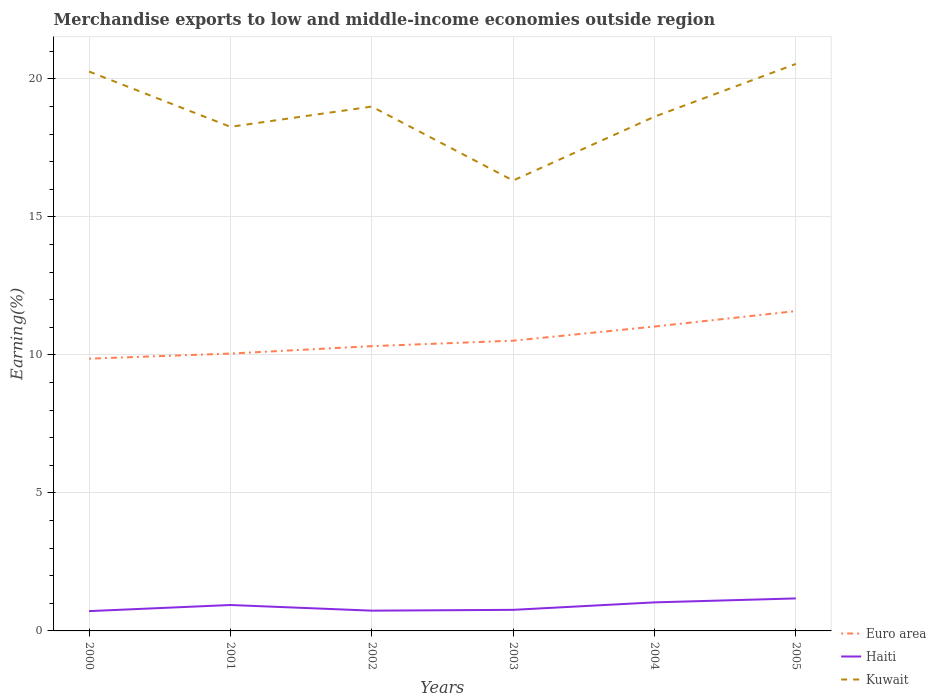How many different coloured lines are there?
Your response must be concise. 3. Across all years, what is the maximum percentage of amount earned from merchandise exports in Euro area?
Your response must be concise. 9.86. What is the total percentage of amount earned from merchandise exports in Haiti in the graph?
Give a very brief answer. -0.32. What is the difference between the highest and the second highest percentage of amount earned from merchandise exports in Kuwait?
Provide a short and direct response. 4.22. What is the difference between the highest and the lowest percentage of amount earned from merchandise exports in Kuwait?
Your answer should be compact. 3. Is the percentage of amount earned from merchandise exports in Haiti strictly greater than the percentage of amount earned from merchandise exports in Euro area over the years?
Ensure brevity in your answer.  Yes. How many years are there in the graph?
Give a very brief answer. 6. Does the graph contain any zero values?
Make the answer very short. No. Does the graph contain grids?
Your answer should be compact. Yes. How many legend labels are there?
Keep it short and to the point. 3. What is the title of the graph?
Give a very brief answer. Merchandise exports to low and middle-income economies outside region. Does "France" appear as one of the legend labels in the graph?
Provide a short and direct response. No. What is the label or title of the X-axis?
Provide a short and direct response. Years. What is the label or title of the Y-axis?
Offer a terse response. Earning(%). What is the Earning(%) of Euro area in 2000?
Your answer should be very brief. 9.86. What is the Earning(%) of Haiti in 2000?
Offer a very short reply. 0.72. What is the Earning(%) in Kuwait in 2000?
Ensure brevity in your answer.  20.26. What is the Earning(%) in Euro area in 2001?
Your response must be concise. 10.05. What is the Earning(%) of Haiti in 2001?
Your answer should be very brief. 0.94. What is the Earning(%) in Kuwait in 2001?
Offer a terse response. 18.26. What is the Earning(%) of Euro area in 2002?
Provide a succinct answer. 10.32. What is the Earning(%) in Haiti in 2002?
Your answer should be compact. 0.73. What is the Earning(%) of Kuwait in 2002?
Your answer should be compact. 18.99. What is the Earning(%) of Euro area in 2003?
Ensure brevity in your answer.  10.51. What is the Earning(%) in Haiti in 2003?
Make the answer very short. 0.76. What is the Earning(%) in Kuwait in 2003?
Your answer should be compact. 16.31. What is the Earning(%) of Euro area in 2004?
Provide a short and direct response. 11.03. What is the Earning(%) in Haiti in 2004?
Make the answer very short. 1.03. What is the Earning(%) of Kuwait in 2004?
Your answer should be very brief. 18.63. What is the Earning(%) of Euro area in 2005?
Your answer should be very brief. 11.59. What is the Earning(%) in Haiti in 2005?
Provide a succinct answer. 1.18. What is the Earning(%) of Kuwait in 2005?
Your response must be concise. 20.54. Across all years, what is the maximum Earning(%) in Euro area?
Offer a terse response. 11.59. Across all years, what is the maximum Earning(%) of Haiti?
Keep it short and to the point. 1.18. Across all years, what is the maximum Earning(%) in Kuwait?
Give a very brief answer. 20.54. Across all years, what is the minimum Earning(%) of Euro area?
Make the answer very short. 9.86. Across all years, what is the minimum Earning(%) of Haiti?
Keep it short and to the point. 0.72. Across all years, what is the minimum Earning(%) of Kuwait?
Give a very brief answer. 16.31. What is the total Earning(%) of Euro area in the graph?
Provide a short and direct response. 63.35. What is the total Earning(%) of Haiti in the graph?
Offer a very short reply. 5.37. What is the total Earning(%) of Kuwait in the graph?
Your response must be concise. 113. What is the difference between the Earning(%) in Euro area in 2000 and that in 2001?
Provide a short and direct response. -0.19. What is the difference between the Earning(%) of Haiti in 2000 and that in 2001?
Offer a very short reply. -0.22. What is the difference between the Earning(%) of Kuwait in 2000 and that in 2001?
Provide a succinct answer. 2. What is the difference between the Earning(%) in Euro area in 2000 and that in 2002?
Your answer should be very brief. -0.45. What is the difference between the Earning(%) of Haiti in 2000 and that in 2002?
Your answer should be compact. -0.02. What is the difference between the Earning(%) of Kuwait in 2000 and that in 2002?
Your answer should be very brief. 1.27. What is the difference between the Earning(%) of Euro area in 2000 and that in 2003?
Provide a succinct answer. -0.65. What is the difference between the Earning(%) in Haiti in 2000 and that in 2003?
Your response must be concise. -0.05. What is the difference between the Earning(%) in Kuwait in 2000 and that in 2003?
Give a very brief answer. 3.95. What is the difference between the Earning(%) of Euro area in 2000 and that in 2004?
Your answer should be compact. -1.16. What is the difference between the Earning(%) in Haiti in 2000 and that in 2004?
Provide a short and direct response. -0.32. What is the difference between the Earning(%) of Kuwait in 2000 and that in 2004?
Your answer should be very brief. 1.63. What is the difference between the Earning(%) in Euro area in 2000 and that in 2005?
Your response must be concise. -1.72. What is the difference between the Earning(%) of Haiti in 2000 and that in 2005?
Offer a terse response. -0.46. What is the difference between the Earning(%) in Kuwait in 2000 and that in 2005?
Your answer should be compact. -0.28. What is the difference between the Earning(%) of Euro area in 2001 and that in 2002?
Provide a short and direct response. -0.27. What is the difference between the Earning(%) in Haiti in 2001 and that in 2002?
Offer a terse response. 0.2. What is the difference between the Earning(%) in Kuwait in 2001 and that in 2002?
Your response must be concise. -0.73. What is the difference between the Earning(%) of Euro area in 2001 and that in 2003?
Your answer should be compact. -0.47. What is the difference between the Earning(%) of Haiti in 2001 and that in 2003?
Give a very brief answer. 0.18. What is the difference between the Earning(%) of Kuwait in 2001 and that in 2003?
Provide a succinct answer. 1.95. What is the difference between the Earning(%) in Euro area in 2001 and that in 2004?
Ensure brevity in your answer.  -0.98. What is the difference between the Earning(%) in Haiti in 2001 and that in 2004?
Give a very brief answer. -0.1. What is the difference between the Earning(%) of Kuwait in 2001 and that in 2004?
Offer a terse response. -0.37. What is the difference between the Earning(%) of Euro area in 2001 and that in 2005?
Provide a short and direct response. -1.54. What is the difference between the Earning(%) in Haiti in 2001 and that in 2005?
Ensure brevity in your answer.  -0.24. What is the difference between the Earning(%) in Kuwait in 2001 and that in 2005?
Provide a short and direct response. -2.28. What is the difference between the Earning(%) in Euro area in 2002 and that in 2003?
Offer a very short reply. -0.2. What is the difference between the Earning(%) of Haiti in 2002 and that in 2003?
Give a very brief answer. -0.03. What is the difference between the Earning(%) of Kuwait in 2002 and that in 2003?
Make the answer very short. 2.68. What is the difference between the Earning(%) in Euro area in 2002 and that in 2004?
Your answer should be compact. -0.71. What is the difference between the Earning(%) in Haiti in 2002 and that in 2004?
Ensure brevity in your answer.  -0.3. What is the difference between the Earning(%) in Kuwait in 2002 and that in 2004?
Your answer should be very brief. 0.37. What is the difference between the Earning(%) in Euro area in 2002 and that in 2005?
Provide a short and direct response. -1.27. What is the difference between the Earning(%) of Haiti in 2002 and that in 2005?
Provide a succinct answer. -0.44. What is the difference between the Earning(%) of Kuwait in 2002 and that in 2005?
Keep it short and to the point. -1.55. What is the difference between the Earning(%) of Euro area in 2003 and that in 2004?
Give a very brief answer. -0.51. What is the difference between the Earning(%) of Haiti in 2003 and that in 2004?
Your response must be concise. -0.27. What is the difference between the Earning(%) of Kuwait in 2003 and that in 2004?
Provide a short and direct response. -2.31. What is the difference between the Earning(%) in Euro area in 2003 and that in 2005?
Offer a terse response. -1.07. What is the difference between the Earning(%) of Haiti in 2003 and that in 2005?
Your answer should be very brief. -0.41. What is the difference between the Earning(%) of Kuwait in 2003 and that in 2005?
Keep it short and to the point. -4.22. What is the difference between the Earning(%) of Euro area in 2004 and that in 2005?
Offer a terse response. -0.56. What is the difference between the Earning(%) of Haiti in 2004 and that in 2005?
Offer a terse response. -0.14. What is the difference between the Earning(%) of Kuwait in 2004 and that in 2005?
Your answer should be compact. -1.91. What is the difference between the Earning(%) of Euro area in 2000 and the Earning(%) of Haiti in 2001?
Your response must be concise. 8.92. What is the difference between the Earning(%) of Euro area in 2000 and the Earning(%) of Kuwait in 2001?
Your answer should be compact. -8.4. What is the difference between the Earning(%) in Haiti in 2000 and the Earning(%) in Kuwait in 2001?
Offer a very short reply. -17.54. What is the difference between the Earning(%) of Euro area in 2000 and the Earning(%) of Haiti in 2002?
Keep it short and to the point. 9.13. What is the difference between the Earning(%) of Euro area in 2000 and the Earning(%) of Kuwait in 2002?
Keep it short and to the point. -9.13. What is the difference between the Earning(%) in Haiti in 2000 and the Earning(%) in Kuwait in 2002?
Provide a short and direct response. -18.28. What is the difference between the Earning(%) in Euro area in 2000 and the Earning(%) in Haiti in 2003?
Provide a short and direct response. 9.1. What is the difference between the Earning(%) in Euro area in 2000 and the Earning(%) in Kuwait in 2003?
Keep it short and to the point. -6.45. What is the difference between the Earning(%) of Haiti in 2000 and the Earning(%) of Kuwait in 2003?
Your answer should be compact. -15.6. What is the difference between the Earning(%) of Euro area in 2000 and the Earning(%) of Haiti in 2004?
Keep it short and to the point. 8.83. What is the difference between the Earning(%) in Euro area in 2000 and the Earning(%) in Kuwait in 2004?
Ensure brevity in your answer.  -8.77. What is the difference between the Earning(%) of Haiti in 2000 and the Earning(%) of Kuwait in 2004?
Offer a terse response. -17.91. What is the difference between the Earning(%) of Euro area in 2000 and the Earning(%) of Haiti in 2005?
Your answer should be very brief. 8.68. What is the difference between the Earning(%) of Euro area in 2000 and the Earning(%) of Kuwait in 2005?
Your answer should be compact. -10.68. What is the difference between the Earning(%) of Haiti in 2000 and the Earning(%) of Kuwait in 2005?
Offer a very short reply. -19.82. What is the difference between the Earning(%) in Euro area in 2001 and the Earning(%) in Haiti in 2002?
Make the answer very short. 9.31. What is the difference between the Earning(%) of Euro area in 2001 and the Earning(%) of Kuwait in 2002?
Your answer should be compact. -8.95. What is the difference between the Earning(%) of Haiti in 2001 and the Earning(%) of Kuwait in 2002?
Your answer should be very brief. -18.05. What is the difference between the Earning(%) in Euro area in 2001 and the Earning(%) in Haiti in 2003?
Your answer should be compact. 9.28. What is the difference between the Earning(%) of Euro area in 2001 and the Earning(%) of Kuwait in 2003?
Give a very brief answer. -6.27. What is the difference between the Earning(%) in Haiti in 2001 and the Earning(%) in Kuwait in 2003?
Give a very brief answer. -15.38. What is the difference between the Earning(%) in Euro area in 2001 and the Earning(%) in Haiti in 2004?
Offer a very short reply. 9.01. What is the difference between the Earning(%) of Euro area in 2001 and the Earning(%) of Kuwait in 2004?
Give a very brief answer. -8.58. What is the difference between the Earning(%) of Haiti in 2001 and the Earning(%) of Kuwait in 2004?
Ensure brevity in your answer.  -17.69. What is the difference between the Earning(%) of Euro area in 2001 and the Earning(%) of Haiti in 2005?
Provide a short and direct response. 8.87. What is the difference between the Earning(%) of Euro area in 2001 and the Earning(%) of Kuwait in 2005?
Your answer should be very brief. -10.49. What is the difference between the Earning(%) of Haiti in 2001 and the Earning(%) of Kuwait in 2005?
Provide a short and direct response. -19.6. What is the difference between the Earning(%) in Euro area in 2002 and the Earning(%) in Haiti in 2003?
Offer a terse response. 9.55. What is the difference between the Earning(%) of Euro area in 2002 and the Earning(%) of Kuwait in 2003?
Your answer should be compact. -6. What is the difference between the Earning(%) of Haiti in 2002 and the Earning(%) of Kuwait in 2003?
Provide a succinct answer. -15.58. What is the difference between the Earning(%) of Euro area in 2002 and the Earning(%) of Haiti in 2004?
Your response must be concise. 9.28. What is the difference between the Earning(%) in Euro area in 2002 and the Earning(%) in Kuwait in 2004?
Keep it short and to the point. -8.31. What is the difference between the Earning(%) of Haiti in 2002 and the Earning(%) of Kuwait in 2004?
Your response must be concise. -17.89. What is the difference between the Earning(%) of Euro area in 2002 and the Earning(%) of Haiti in 2005?
Your answer should be very brief. 9.14. What is the difference between the Earning(%) of Euro area in 2002 and the Earning(%) of Kuwait in 2005?
Your response must be concise. -10.22. What is the difference between the Earning(%) in Haiti in 2002 and the Earning(%) in Kuwait in 2005?
Give a very brief answer. -19.8. What is the difference between the Earning(%) in Euro area in 2003 and the Earning(%) in Haiti in 2004?
Offer a very short reply. 9.48. What is the difference between the Earning(%) of Euro area in 2003 and the Earning(%) of Kuwait in 2004?
Your answer should be compact. -8.11. What is the difference between the Earning(%) in Haiti in 2003 and the Earning(%) in Kuwait in 2004?
Give a very brief answer. -17.86. What is the difference between the Earning(%) of Euro area in 2003 and the Earning(%) of Haiti in 2005?
Your response must be concise. 9.34. What is the difference between the Earning(%) in Euro area in 2003 and the Earning(%) in Kuwait in 2005?
Your answer should be very brief. -10.03. What is the difference between the Earning(%) in Haiti in 2003 and the Earning(%) in Kuwait in 2005?
Your response must be concise. -19.77. What is the difference between the Earning(%) in Euro area in 2004 and the Earning(%) in Haiti in 2005?
Make the answer very short. 9.85. What is the difference between the Earning(%) of Euro area in 2004 and the Earning(%) of Kuwait in 2005?
Your answer should be compact. -9.51. What is the difference between the Earning(%) in Haiti in 2004 and the Earning(%) in Kuwait in 2005?
Give a very brief answer. -19.5. What is the average Earning(%) in Euro area per year?
Give a very brief answer. 10.56. What is the average Earning(%) of Haiti per year?
Keep it short and to the point. 0.89. What is the average Earning(%) of Kuwait per year?
Provide a short and direct response. 18.83. In the year 2000, what is the difference between the Earning(%) in Euro area and Earning(%) in Haiti?
Make the answer very short. 9.14. In the year 2000, what is the difference between the Earning(%) in Euro area and Earning(%) in Kuwait?
Offer a terse response. -10.4. In the year 2000, what is the difference between the Earning(%) of Haiti and Earning(%) of Kuwait?
Give a very brief answer. -19.54. In the year 2001, what is the difference between the Earning(%) of Euro area and Earning(%) of Haiti?
Offer a very short reply. 9.11. In the year 2001, what is the difference between the Earning(%) in Euro area and Earning(%) in Kuwait?
Keep it short and to the point. -8.21. In the year 2001, what is the difference between the Earning(%) of Haiti and Earning(%) of Kuwait?
Your response must be concise. -17.32. In the year 2002, what is the difference between the Earning(%) in Euro area and Earning(%) in Haiti?
Keep it short and to the point. 9.58. In the year 2002, what is the difference between the Earning(%) in Euro area and Earning(%) in Kuwait?
Ensure brevity in your answer.  -8.68. In the year 2002, what is the difference between the Earning(%) in Haiti and Earning(%) in Kuwait?
Offer a terse response. -18.26. In the year 2003, what is the difference between the Earning(%) in Euro area and Earning(%) in Haiti?
Provide a short and direct response. 9.75. In the year 2003, what is the difference between the Earning(%) in Euro area and Earning(%) in Kuwait?
Your response must be concise. -5.8. In the year 2003, what is the difference between the Earning(%) in Haiti and Earning(%) in Kuwait?
Offer a terse response. -15.55. In the year 2004, what is the difference between the Earning(%) in Euro area and Earning(%) in Haiti?
Ensure brevity in your answer.  9.99. In the year 2004, what is the difference between the Earning(%) in Euro area and Earning(%) in Kuwait?
Make the answer very short. -7.6. In the year 2004, what is the difference between the Earning(%) in Haiti and Earning(%) in Kuwait?
Offer a terse response. -17.59. In the year 2005, what is the difference between the Earning(%) in Euro area and Earning(%) in Haiti?
Offer a terse response. 10.41. In the year 2005, what is the difference between the Earning(%) in Euro area and Earning(%) in Kuwait?
Give a very brief answer. -8.95. In the year 2005, what is the difference between the Earning(%) of Haiti and Earning(%) of Kuwait?
Provide a short and direct response. -19.36. What is the ratio of the Earning(%) in Euro area in 2000 to that in 2001?
Give a very brief answer. 0.98. What is the ratio of the Earning(%) of Haiti in 2000 to that in 2001?
Your response must be concise. 0.76. What is the ratio of the Earning(%) in Kuwait in 2000 to that in 2001?
Make the answer very short. 1.11. What is the ratio of the Earning(%) in Euro area in 2000 to that in 2002?
Your answer should be compact. 0.96. What is the ratio of the Earning(%) of Haiti in 2000 to that in 2002?
Your answer should be very brief. 0.98. What is the ratio of the Earning(%) of Kuwait in 2000 to that in 2002?
Your answer should be compact. 1.07. What is the ratio of the Earning(%) in Euro area in 2000 to that in 2003?
Ensure brevity in your answer.  0.94. What is the ratio of the Earning(%) of Kuwait in 2000 to that in 2003?
Keep it short and to the point. 1.24. What is the ratio of the Earning(%) in Euro area in 2000 to that in 2004?
Your answer should be compact. 0.89. What is the ratio of the Earning(%) in Haiti in 2000 to that in 2004?
Give a very brief answer. 0.69. What is the ratio of the Earning(%) of Kuwait in 2000 to that in 2004?
Your answer should be very brief. 1.09. What is the ratio of the Earning(%) in Euro area in 2000 to that in 2005?
Offer a very short reply. 0.85. What is the ratio of the Earning(%) of Haiti in 2000 to that in 2005?
Your answer should be compact. 0.61. What is the ratio of the Earning(%) in Kuwait in 2000 to that in 2005?
Your response must be concise. 0.99. What is the ratio of the Earning(%) in Euro area in 2001 to that in 2002?
Provide a short and direct response. 0.97. What is the ratio of the Earning(%) of Haiti in 2001 to that in 2002?
Your answer should be very brief. 1.28. What is the ratio of the Earning(%) of Kuwait in 2001 to that in 2002?
Ensure brevity in your answer.  0.96. What is the ratio of the Earning(%) of Euro area in 2001 to that in 2003?
Your answer should be compact. 0.96. What is the ratio of the Earning(%) in Haiti in 2001 to that in 2003?
Your answer should be compact. 1.23. What is the ratio of the Earning(%) in Kuwait in 2001 to that in 2003?
Offer a very short reply. 1.12. What is the ratio of the Earning(%) in Euro area in 2001 to that in 2004?
Give a very brief answer. 0.91. What is the ratio of the Earning(%) of Haiti in 2001 to that in 2004?
Offer a very short reply. 0.91. What is the ratio of the Earning(%) of Kuwait in 2001 to that in 2004?
Your answer should be very brief. 0.98. What is the ratio of the Earning(%) in Euro area in 2001 to that in 2005?
Offer a terse response. 0.87. What is the ratio of the Earning(%) of Haiti in 2001 to that in 2005?
Make the answer very short. 0.8. What is the ratio of the Earning(%) of Kuwait in 2001 to that in 2005?
Your answer should be very brief. 0.89. What is the ratio of the Earning(%) of Euro area in 2002 to that in 2003?
Provide a succinct answer. 0.98. What is the ratio of the Earning(%) in Haiti in 2002 to that in 2003?
Your answer should be compact. 0.96. What is the ratio of the Earning(%) of Kuwait in 2002 to that in 2003?
Your response must be concise. 1.16. What is the ratio of the Earning(%) in Euro area in 2002 to that in 2004?
Your response must be concise. 0.94. What is the ratio of the Earning(%) in Haiti in 2002 to that in 2004?
Keep it short and to the point. 0.71. What is the ratio of the Earning(%) of Kuwait in 2002 to that in 2004?
Ensure brevity in your answer.  1.02. What is the ratio of the Earning(%) of Euro area in 2002 to that in 2005?
Keep it short and to the point. 0.89. What is the ratio of the Earning(%) of Haiti in 2002 to that in 2005?
Give a very brief answer. 0.62. What is the ratio of the Earning(%) of Kuwait in 2002 to that in 2005?
Provide a short and direct response. 0.92. What is the ratio of the Earning(%) of Euro area in 2003 to that in 2004?
Your answer should be very brief. 0.95. What is the ratio of the Earning(%) in Haiti in 2003 to that in 2004?
Your answer should be compact. 0.74. What is the ratio of the Earning(%) in Kuwait in 2003 to that in 2004?
Your response must be concise. 0.88. What is the ratio of the Earning(%) in Euro area in 2003 to that in 2005?
Offer a very short reply. 0.91. What is the ratio of the Earning(%) in Haiti in 2003 to that in 2005?
Provide a succinct answer. 0.65. What is the ratio of the Earning(%) of Kuwait in 2003 to that in 2005?
Provide a succinct answer. 0.79. What is the ratio of the Earning(%) of Euro area in 2004 to that in 2005?
Provide a succinct answer. 0.95. What is the ratio of the Earning(%) in Haiti in 2004 to that in 2005?
Provide a short and direct response. 0.88. What is the ratio of the Earning(%) in Kuwait in 2004 to that in 2005?
Keep it short and to the point. 0.91. What is the difference between the highest and the second highest Earning(%) in Euro area?
Offer a very short reply. 0.56. What is the difference between the highest and the second highest Earning(%) of Haiti?
Ensure brevity in your answer.  0.14. What is the difference between the highest and the second highest Earning(%) of Kuwait?
Make the answer very short. 0.28. What is the difference between the highest and the lowest Earning(%) in Euro area?
Your answer should be very brief. 1.72. What is the difference between the highest and the lowest Earning(%) of Haiti?
Keep it short and to the point. 0.46. What is the difference between the highest and the lowest Earning(%) of Kuwait?
Provide a succinct answer. 4.22. 